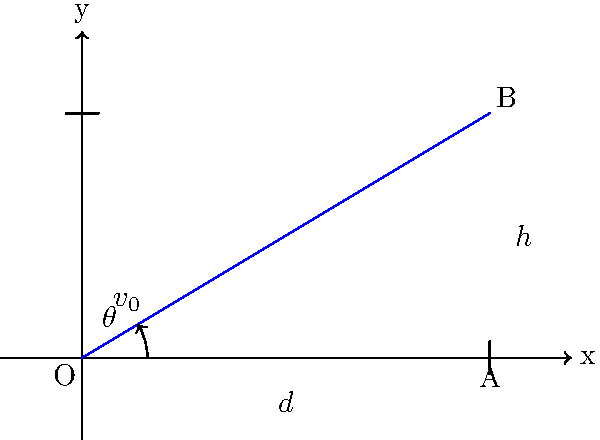In an amusement park fountain display, a water jet is launched from point O with an initial velocity $v_0$ at an angle $\theta$ above the horizontal. The jet reaches a maximum height of $h = 3$ meters and travels a horizontal distance of $d = 5$ meters before hitting the ground. Using trigonometric functions, determine the launch angle $\theta$ of the water jet. To solve this problem, we'll use the equations of projectile motion and trigonometry:

1) The time to reach the maximum height is half the total time of flight. Let's call the total time $t$.

2) Using the vertical motion equation:
   $h = v_0 \sin(\theta) \cdot \frac{t}{2} - \frac{1}{2}g(\frac{t}{2})^2$

3) The horizontal distance is given by:
   $d = v_0 \cos(\theta) \cdot t$

4) Eliminate $t$ from equations (2) and (3):
   $h = d \cdot \tan(\theta) - \frac{gd^2}{2(v_0 \cos(\theta))^2}$

5) Rearrange to get:
   $\frac{2v_0^2}{gd} = \frac{\cos^2(\theta)}{\sin(\theta) - \frac{h}{d}\cos^2(\theta)}$

6) Let $k = \frac{2v_0^2}{gd}$. Then:
   $k = \frac{1}{\tan(\theta) - \frac{h}{d}}$

7) Solve for $\theta$:
   $\theta = \arctan(\frac{1}{k} + \frac{h}{d})$

8) Given $h = 3$ and $d = 5$, we have:
   $\theta = \arctan(\frac{1}{k} + \frac{3}{5})$

9) The value of $k$ depends on $v_0$, which we don't know. However, we can determine $\theta$ without knowing $v_0$ by using the equation:
   $\tan(\theta) = \frac{4h}{d} = \frac{4 \cdot 3}{5} = 2.4$

10) Therefore:
    $\theta = \arctan(2.4)$
Answer: $\theta = \arctan(2.4) \approx 67.4°$ 